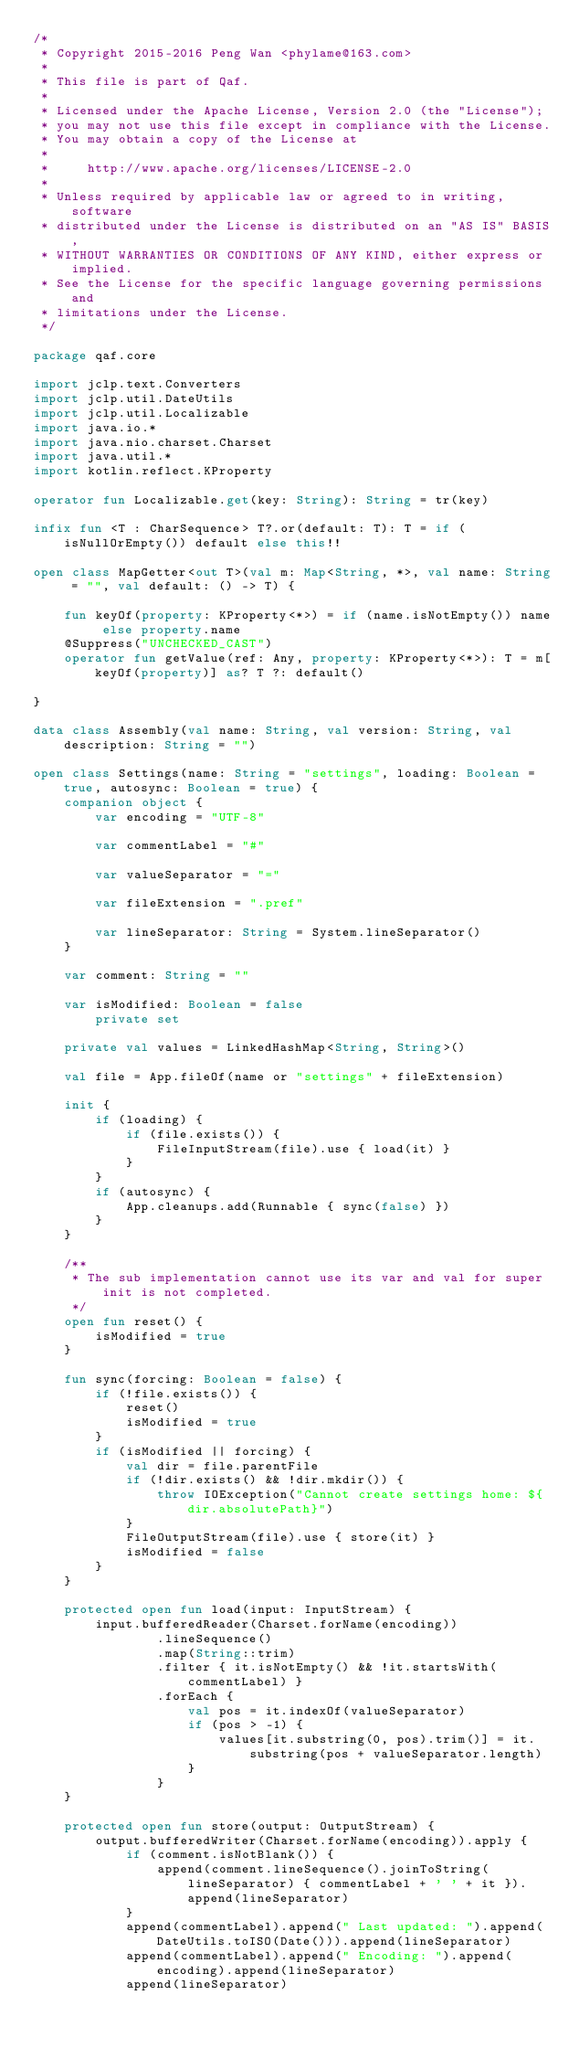Convert code to text. <code><loc_0><loc_0><loc_500><loc_500><_Kotlin_>/*
 * Copyright 2015-2016 Peng Wan <phylame@163.com>
 *
 * This file is part of Qaf.
 *
 * Licensed under the Apache License, Version 2.0 (the "License");
 * you may not use this file except in compliance with the License.
 * You may obtain a copy of the License at
 *
 *     http://www.apache.org/licenses/LICENSE-2.0
 *
 * Unless required by applicable law or agreed to in writing, software
 * distributed under the License is distributed on an "AS IS" BASIS,
 * WITHOUT WARRANTIES OR CONDITIONS OF ANY KIND, either express or implied.
 * See the License for the specific language governing permissions and
 * limitations under the License.
 */

package qaf.core

import jclp.text.Converters
import jclp.util.DateUtils
import jclp.util.Localizable
import java.io.*
import java.nio.charset.Charset
import java.util.*
import kotlin.reflect.KProperty

operator fun Localizable.get(key: String): String = tr(key)

infix fun <T : CharSequence> T?.or(default: T): T = if (isNullOrEmpty()) default else this!!

open class MapGetter<out T>(val m: Map<String, *>, val name: String = "", val default: () -> T) {

    fun keyOf(property: KProperty<*>) = if (name.isNotEmpty()) name else property.name
    @Suppress("UNCHECKED_CAST")
    operator fun getValue(ref: Any, property: KProperty<*>): T = m[keyOf(property)] as? T ?: default()

}

data class Assembly(val name: String, val version: String, val description: String = "")

open class Settings(name: String = "settings", loading: Boolean = true, autosync: Boolean = true) {
    companion object {
        var encoding = "UTF-8"

        var commentLabel = "#"

        var valueSeparator = "="

        var fileExtension = ".pref"

        var lineSeparator: String = System.lineSeparator()
    }

    var comment: String = ""

    var isModified: Boolean = false
        private set

    private val values = LinkedHashMap<String, String>()

    val file = App.fileOf(name or "settings" + fileExtension)

    init {
        if (loading) {
            if (file.exists()) {
                FileInputStream(file).use { load(it) }
            }
        }
        if (autosync) {
            App.cleanups.add(Runnable { sync(false) })
        }
    }

    /**
     * The sub implementation cannot use its var and val for super init is not completed.
     */
    open fun reset() {
        isModified = true
    }

    fun sync(forcing: Boolean = false) {
        if (!file.exists()) {
            reset()
            isModified = true
        }
        if (isModified || forcing) {
            val dir = file.parentFile
            if (!dir.exists() && !dir.mkdir()) {
                throw IOException("Cannot create settings home: ${dir.absolutePath}")
            }
            FileOutputStream(file).use { store(it) }
            isModified = false
        }
    }

    protected open fun load(input: InputStream) {
        input.bufferedReader(Charset.forName(encoding))
                .lineSequence()
                .map(String::trim)
                .filter { it.isNotEmpty() && !it.startsWith(commentLabel) }
                .forEach {
                    val pos = it.indexOf(valueSeparator)
                    if (pos > -1) {
                        values[it.substring(0, pos).trim()] = it.substring(pos + valueSeparator.length)
                    }
                }
    }

    protected open fun store(output: OutputStream) {
        output.bufferedWriter(Charset.forName(encoding)).apply {
            if (comment.isNotBlank()) {
                append(comment.lineSequence().joinToString(lineSeparator) { commentLabel + ' ' + it }).append(lineSeparator)
            }
            append(commentLabel).append(" Last updated: ").append(DateUtils.toISO(Date())).append(lineSeparator)
            append(commentLabel).append(" Encoding: ").append(encoding).append(lineSeparator)
            append(lineSeparator)</code> 